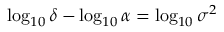Convert formula to latex. <formula><loc_0><loc_0><loc_500><loc_500>\log _ { 1 0 } \delta - \log _ { 1 0 } \alpha = \log _ { 1 0 } \sigma ^ { 2 }</formula> 